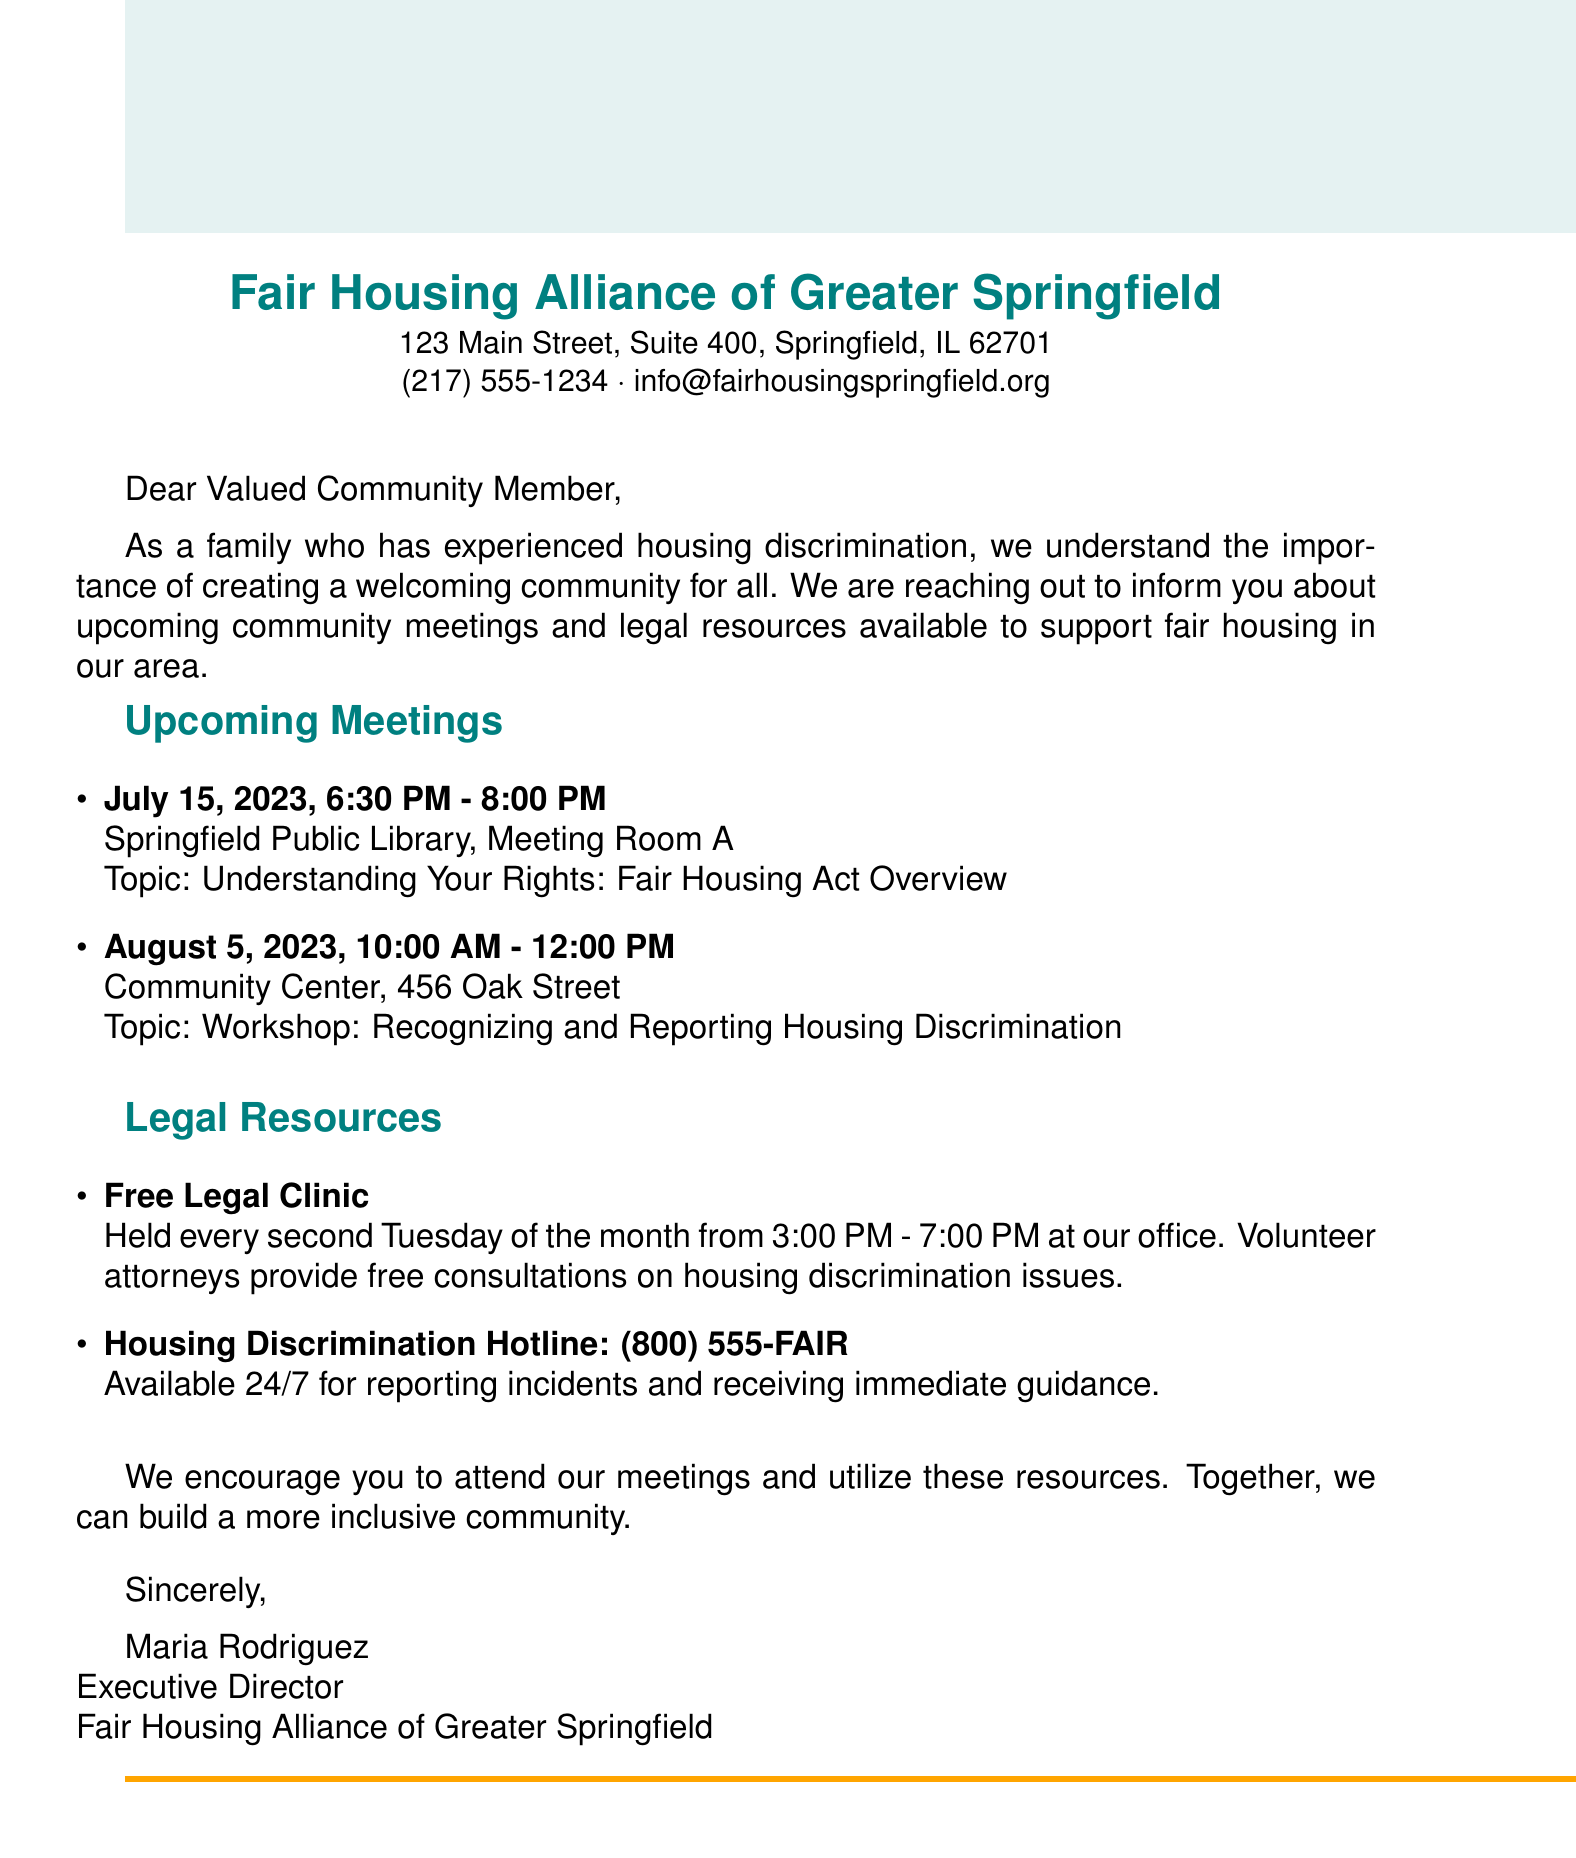What is the name of the organization? The name of the organization is stated in the letterhead of the document, which is "Fair Housing Alliance of Greater Springfield."
Answer: Fair Housing Alliance of Greater Springfield When is the first community meeting? The first community meeting is detailed under the upcoming meetings section, specifically listed with the date and time mentioned.
Answer: July 15, 2023 What topic will be discussed at the second community meeting? The topic for the second meeting can be found under the upcoming meetings section, labeled clearly for that date.
Answer: Workshop: Recognizing and Reporting Housing Discrimination How often is the Free Legal Clinic held? The frequency of the Free Legal Clinic is mentioned in the description provided for that resource in the document.
Answer: Every second Tuesday of the month What is the phone number for the Housing Discrimination Hotline? The phone number is explicitly provided in the document for the hotline resource.
Answer: (800) 555-FAIR What is the purpose of the community meetings? The purpose is outlined in the introduction, emphasizing the importance of the meetings in the context of fair housing.
Answer: Understanding your rights and reporting discrimination How can the community participate in building inclusivity? The document provides a call to action encouraging participation in meetings and resource utilization.
Answer: Attend meetings and utilize resources Who signed the letter? The signatory is mentioned at the end of the document, outlining their position within the organization.
Answer: Maria Rodriguez 